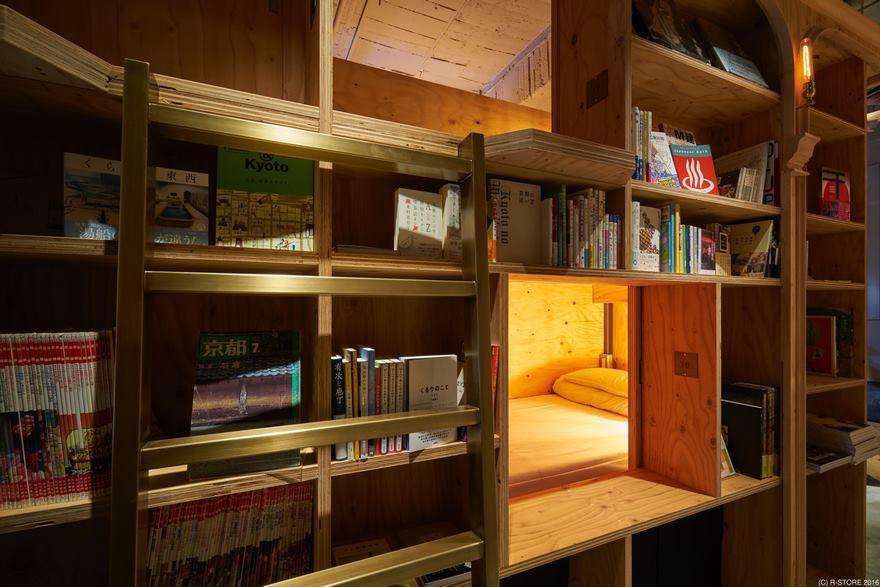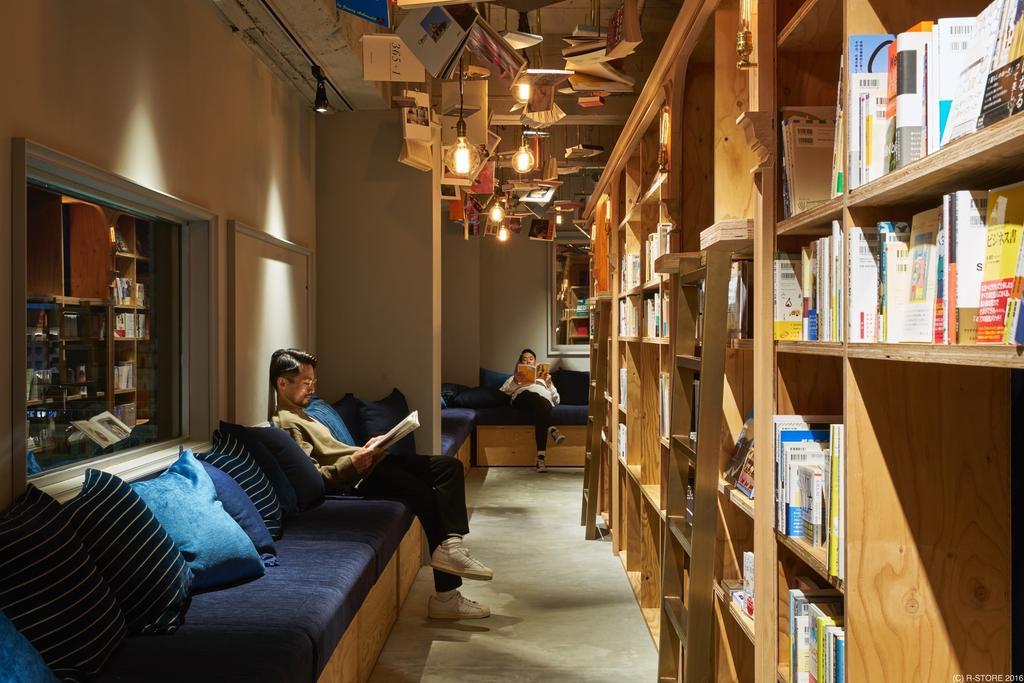The first image is the image on the left, the second image is the image on the right. Assess this claim about the two images: "In one scene, one person is sitting and reading on a blue cushioned bench in front of raw-wood shelves and near a ladder.". Correct or not? Answer yes or no. Yes. The first image is the image on the left, the second image is the image on the right. Examine the images to the left and right. Is the description "A blue seating area sits near the books in the image on the right." accurate? Answer yes or no. Yes. 